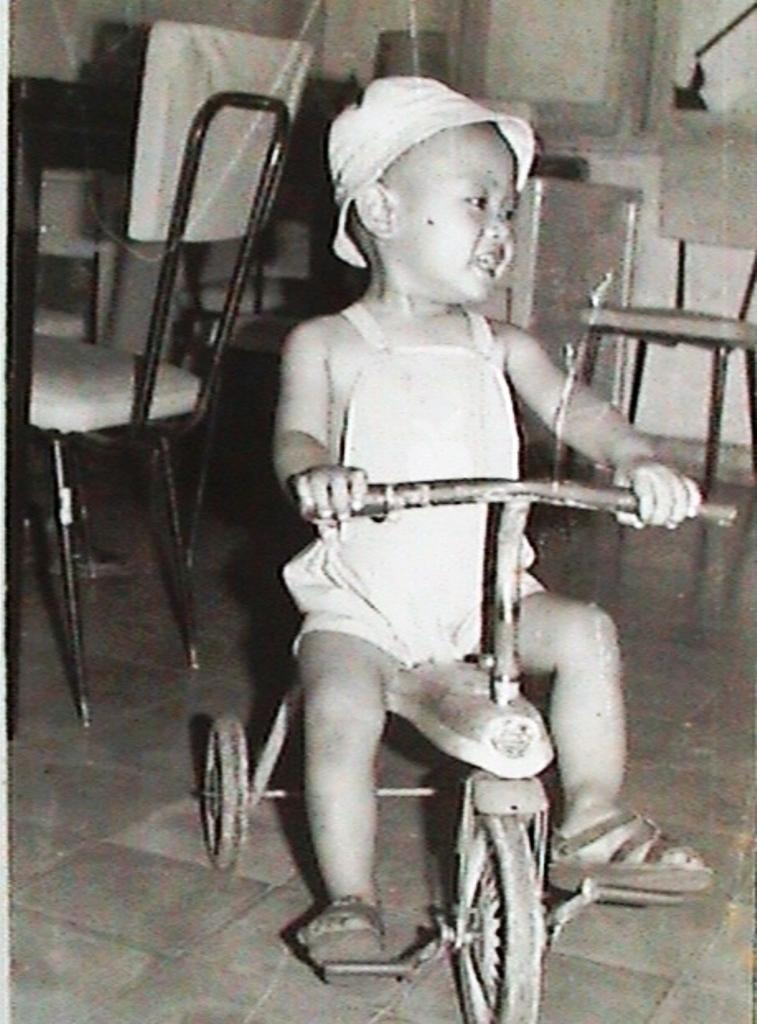What is the main subject of the image? The main subject of the image is a child. What is the child wearing in the image? The child is wearing a cap in the image. What is the child doing in the image? The child is riding a bicycle in the image. What can be seen in the background of the image? There is a chair, a wall, and a window in the background of the image. What type of pie is the child holding in the image? There is no pie present in the image; the child is riding a bicycle. How many apples can be seen on the bicycle in the image? There are no apples present in the image; the child is wearing a cap and riding a bicycle. 